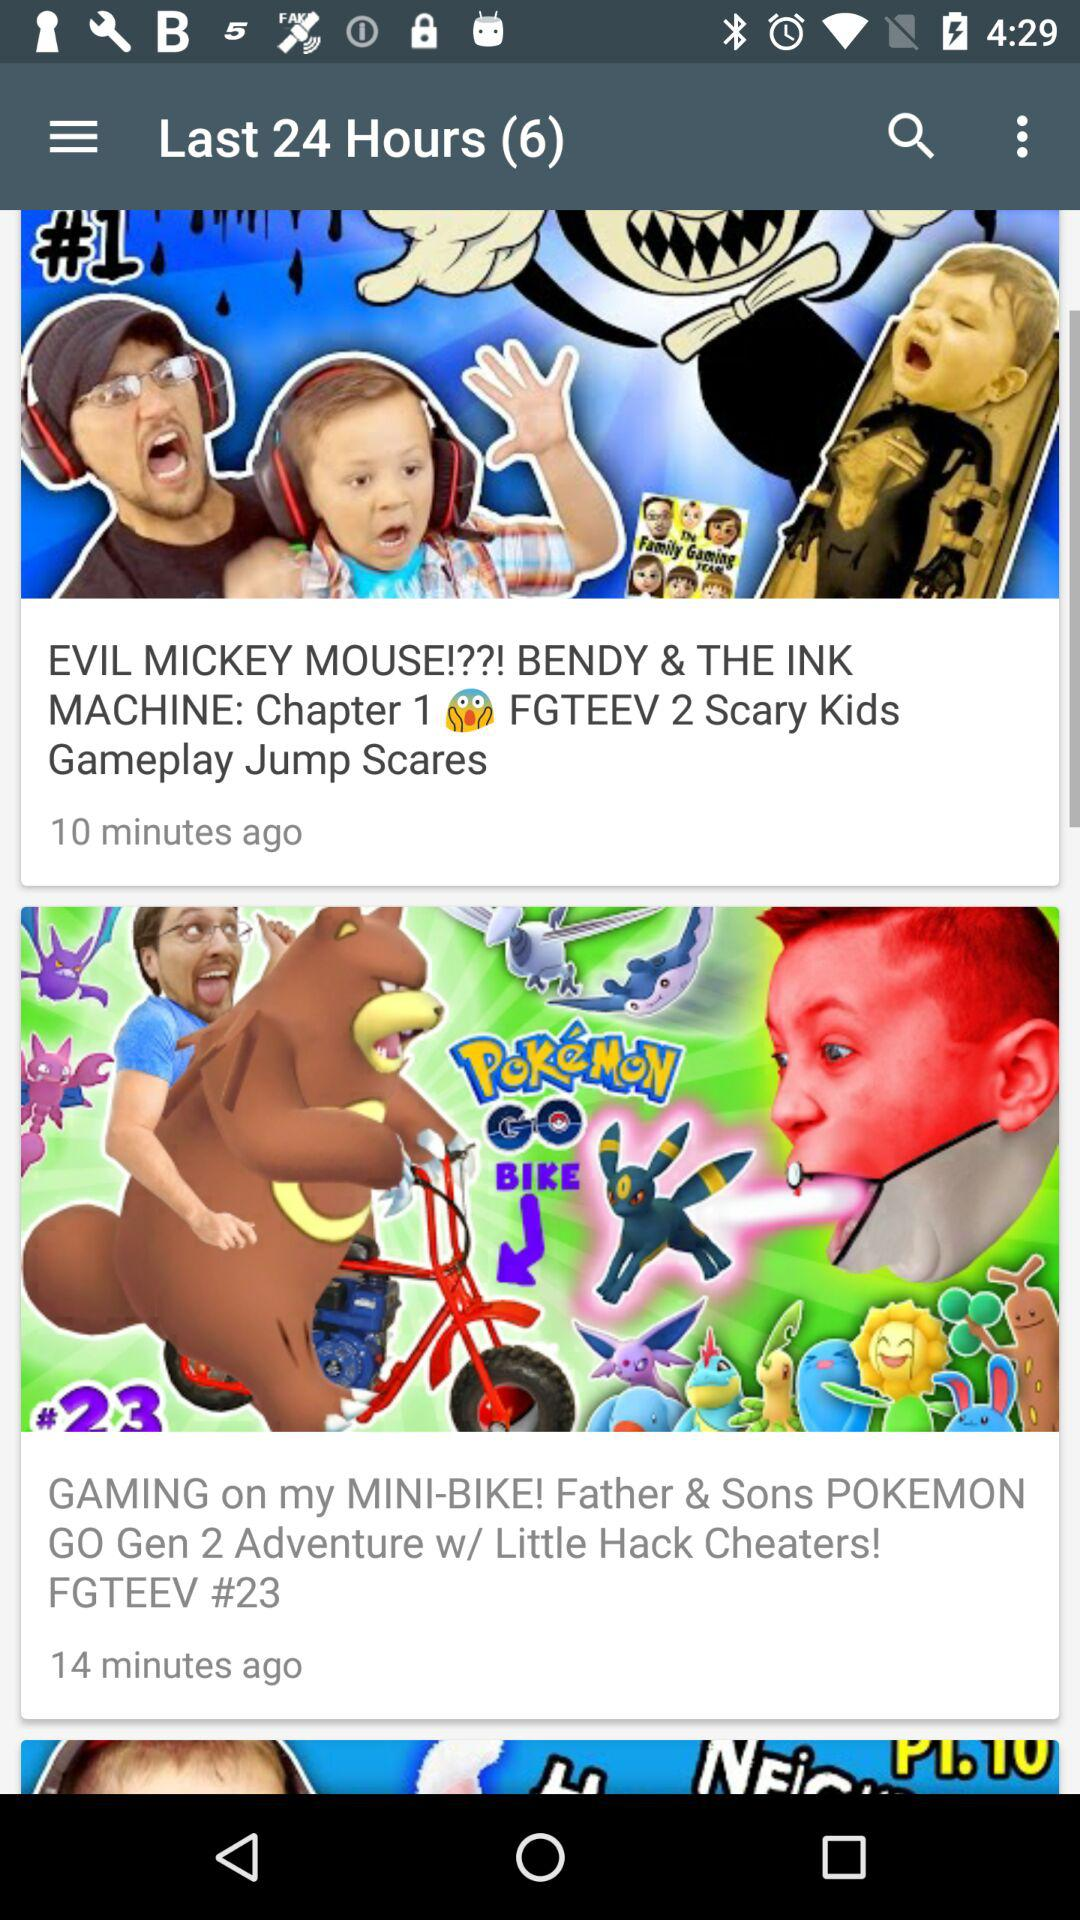What is the name of the game featured in the video, which was posted 14 minutes ago? The name of the game is "POKEMON GO". 